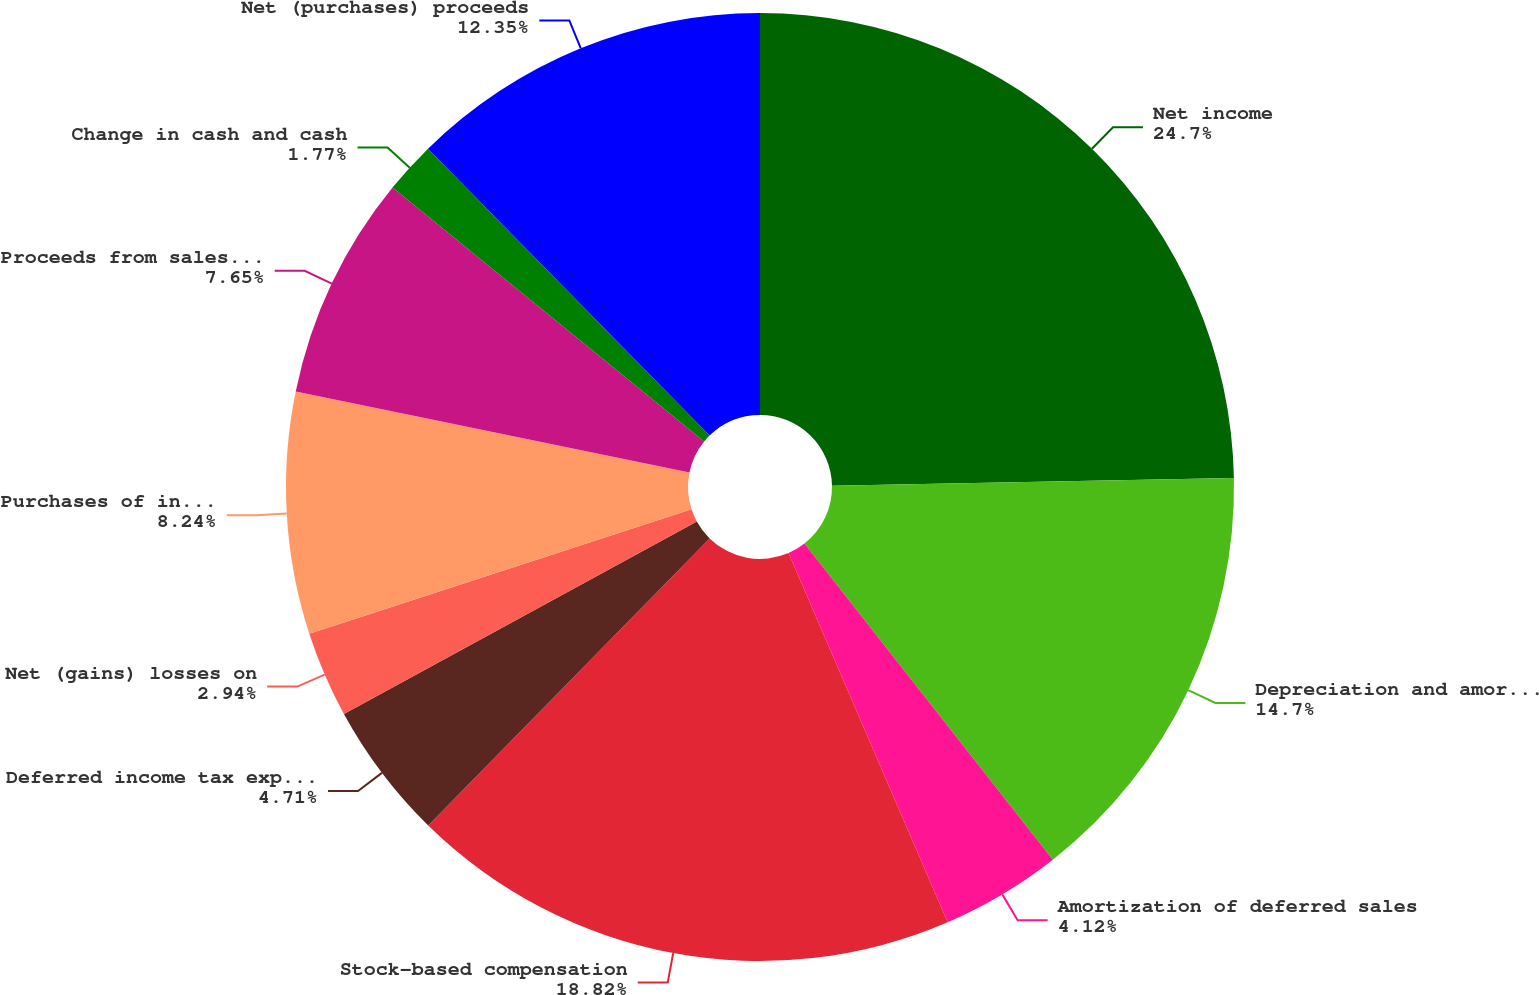Convert chart to OTSL. <chart><loc_0><loc_0><loc_500><loc_500><pie_chart><fcel>Net income<fcel>Depreciation and amortization<fcel>Amortization of deferred sales<fcel>Stock-based compensation<fcel>Deferred income tax expense<fcel>Net (gains) losses on<fcel>Purchases of investments<fcel>Proceeds from sales and<fcel>Change in cash and cash<fcel>Net (purchases) proceeds<nl><fcel>24.7%<fcel>14.7%<fcel>4.12%<fcel>18.82%<fcel>4.71%<fcel>2.94%<fcel>8.24%<fcel>7.65%<fcel>1.77%<fcel>12.35%<nl></chart> 